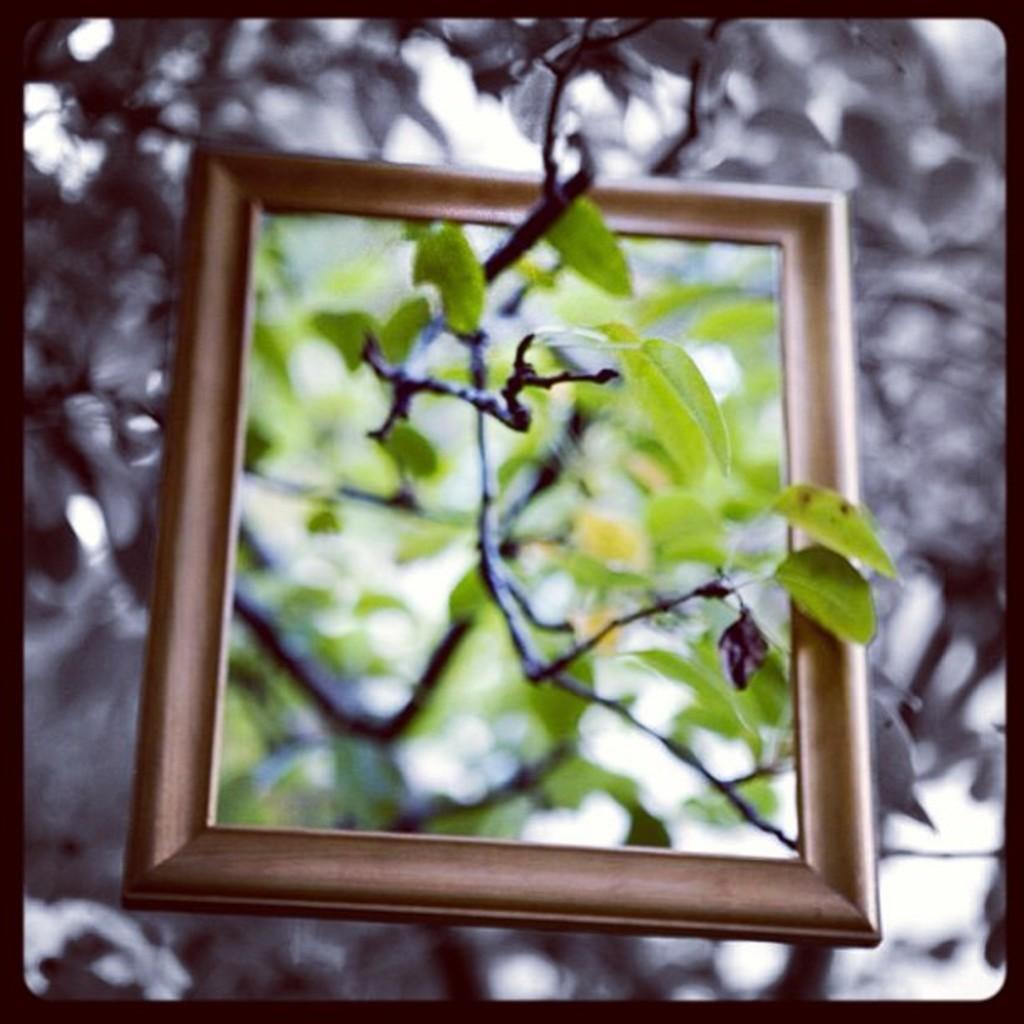Can you describe this image briefly? In this image we can see a frame and a branch of a tree with blur background. 